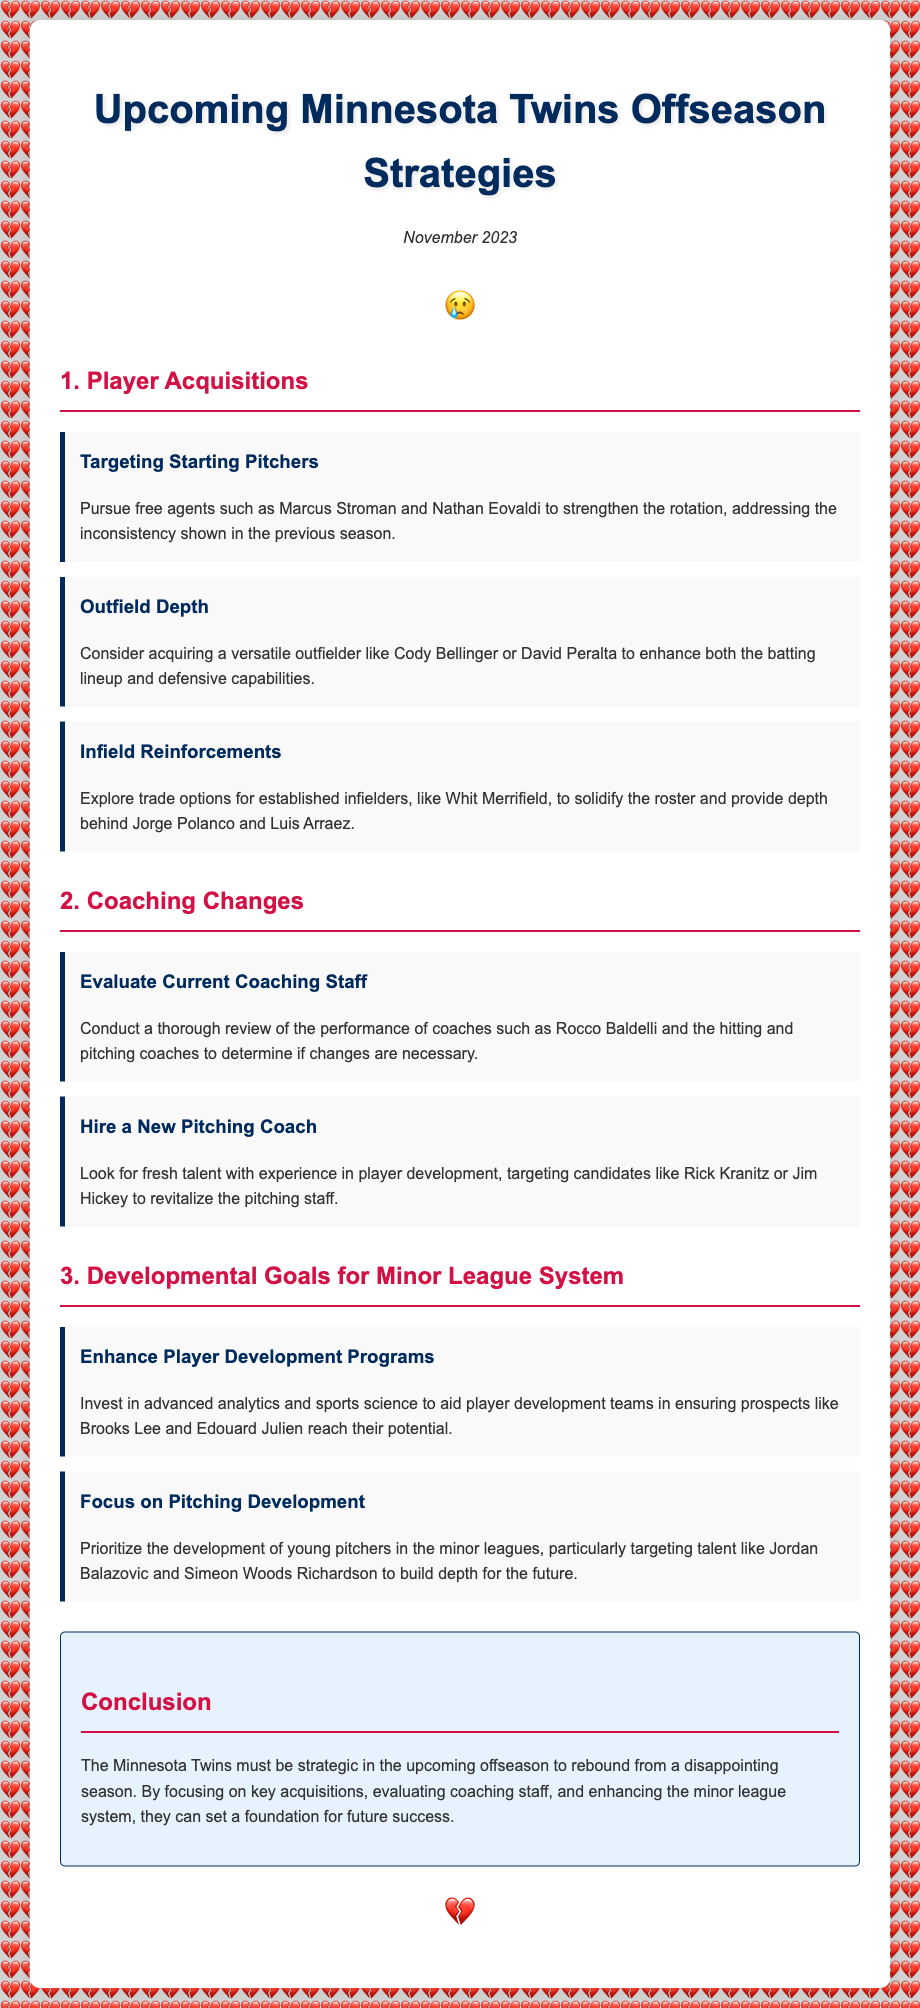What is the primary focus of the offseason strategies? The primary focus outlined in the document includes player acquisitions, coaching changes, and developmental goals.
Answer: player acquisitions, coaching changes, and developmental goals Who are the suggested free agent starting pitchers? The document lists Marcus Stroman and Nathan Eovaldi as free agent targets to strengthen the rotation.
Answer: Marcus Stroman and Nathan Eovaldi What position does Cody Bellinger play? The agenda mentions acquiring Cody Bellinger to enhance outfield depth, indicating he plays in the outfield.
Answer: outfield What is the importance of evaluating the current coaching staff? Evaluating the coaching staff is essential to determine if changes are needed after the previous season.
Answer: to determine if changes are necessary Which area is prioritized for pitcher development? The document mentions focusing on young pitchers in the minor leagues as a key area for development.
Answer: young pitchers in the minor leagues Name one potential new pitching coach mentioned. The agenda suggests considering candidates like Rick Kranitz or Jim Hickey for the pitching coach position.
Answer: Rick Kranitz or Jim Hickey How should the Twins use analytics in their minor league system? The document recommends investing in advanced analytics to aid in player development programs for minor league prospects.
Answer: to aid in player development programs What is a goal for the infield position? The document states the goal of exploring trade options for established infielders to solidify the roster.
Answer: explore trade options for established infielders What is the conclusion's recommendation for the Twins? The conclusion suggests being strategic in the offseason to rebound from a disappointing season.
Answer: be strategic in the offseason 